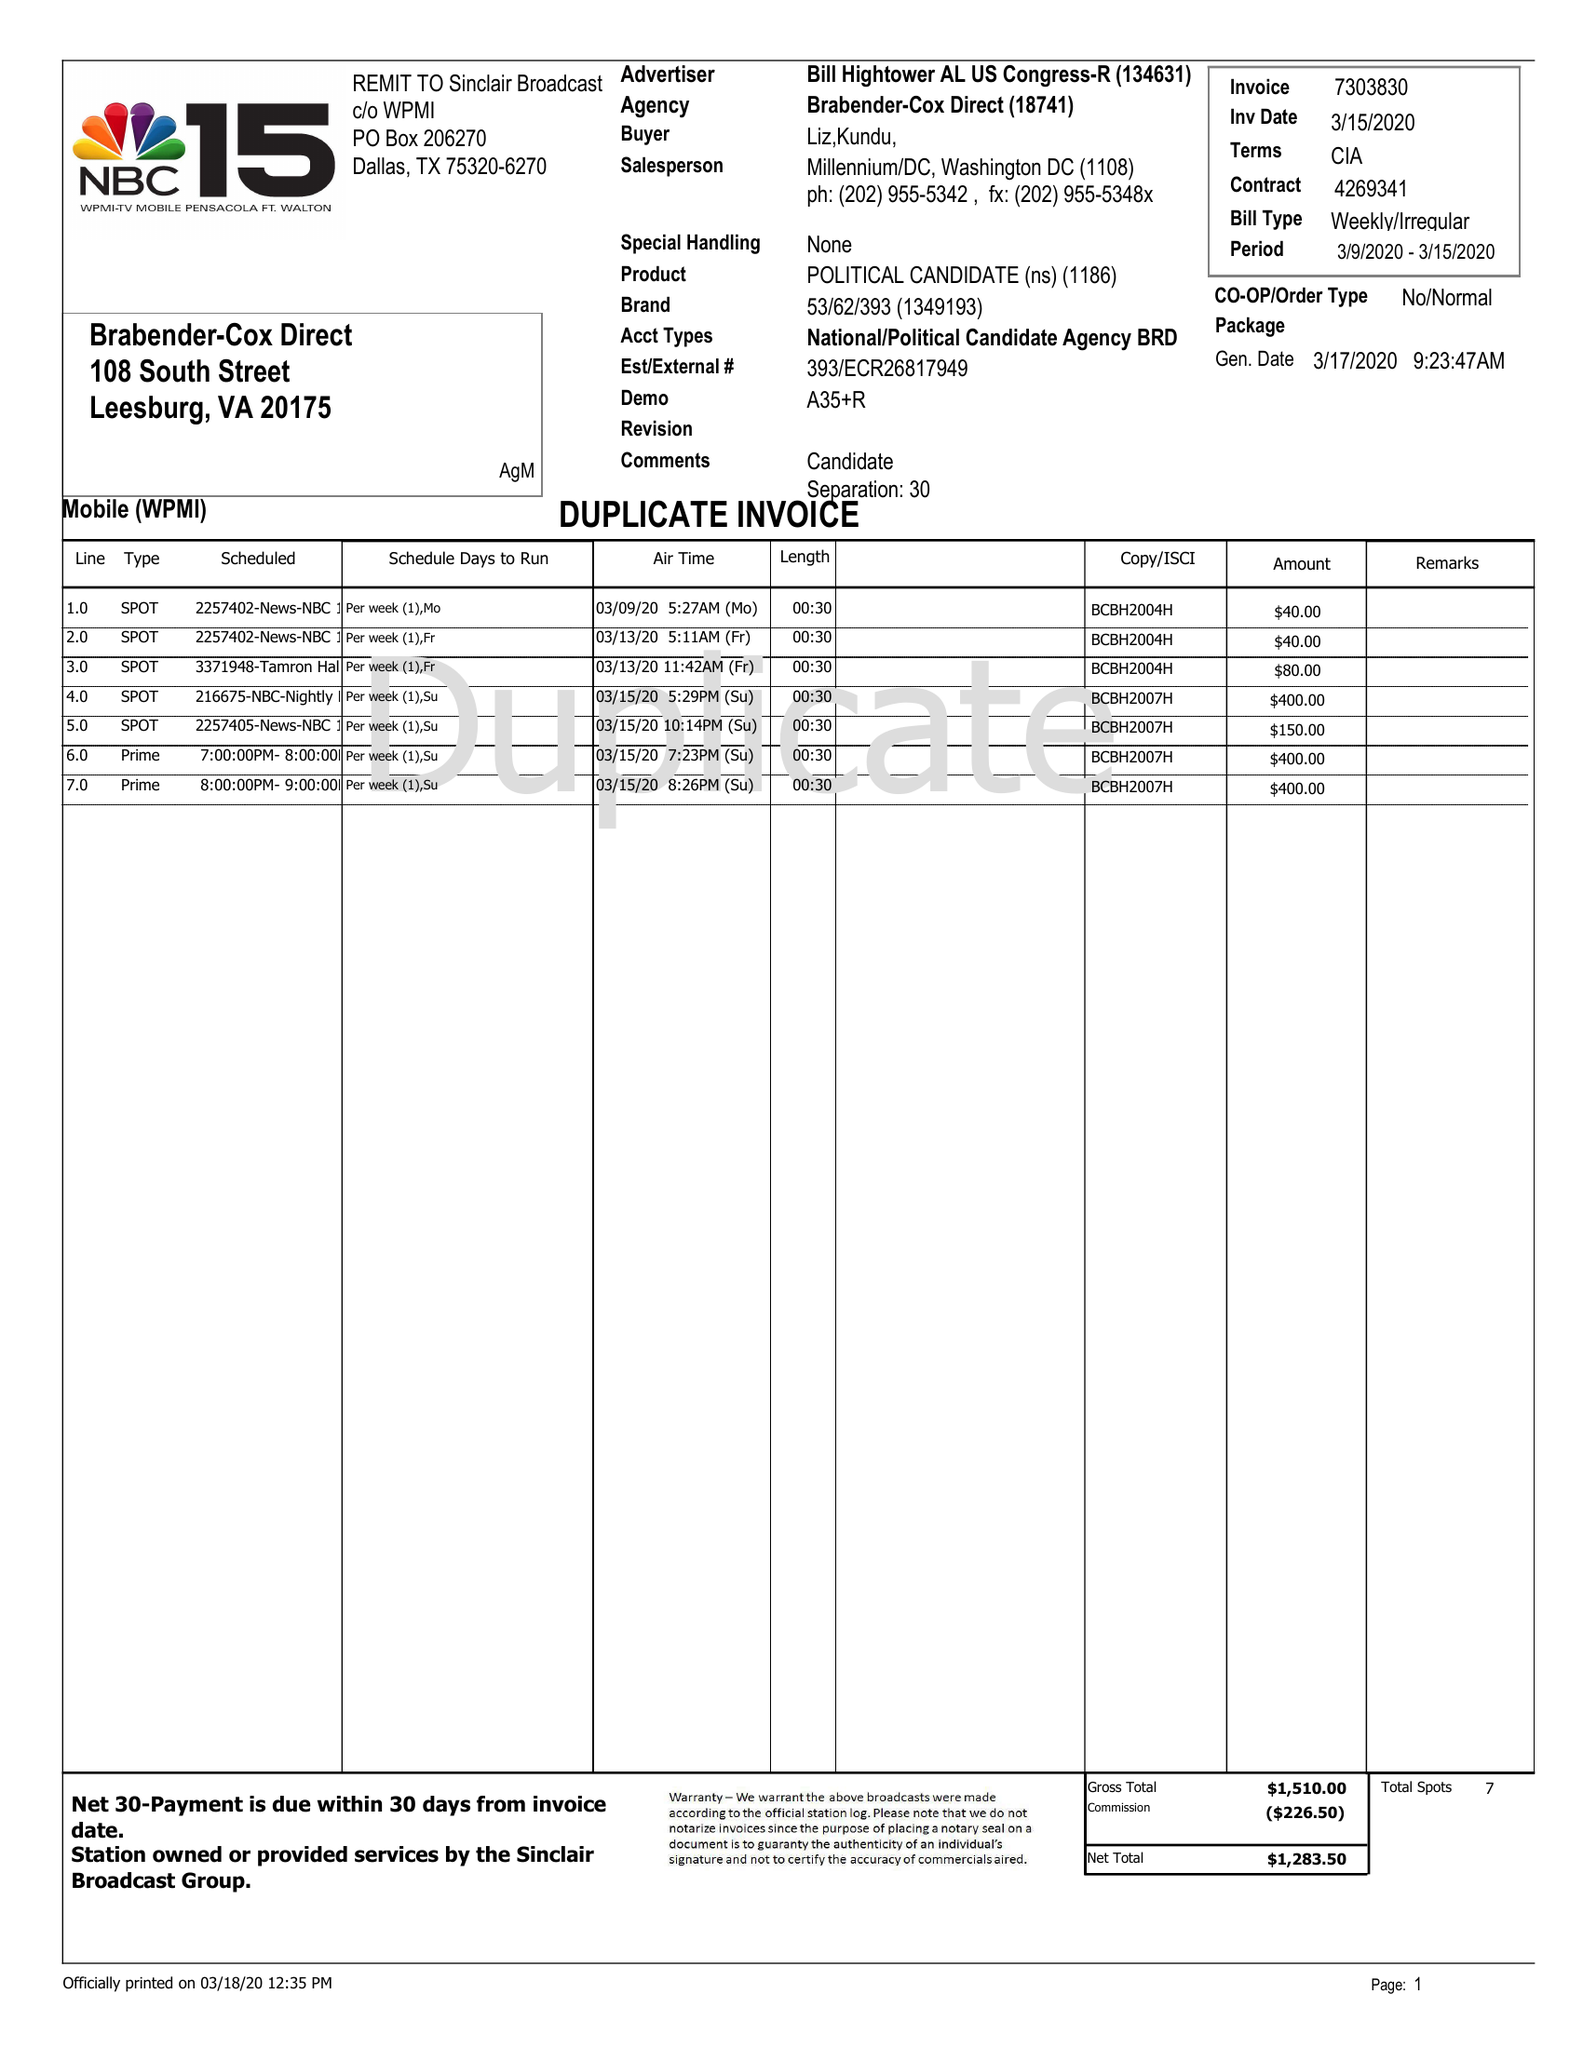What is the value for the flight_from?
Answer the question using a single word or phrase. 03/09/20 